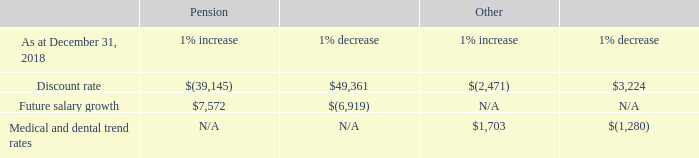30. EMPLOYEE BENEFIT PLANS (cont.)
The above sensitivities are hypothetical and should be used with caution. Changes in amounts based on a one percent variation in assumptions generally cannot be extrapolated because the relationship of the change in assumption to the change in amounts may not be linear. The sensitivities have been calculated independently of changes in other key variables. Changes in one factor may result in changes in another, which could amplify or reduce certain sensitivities.
The Company expects to make contributions of $5.1 million to the defined benefit plans and $0.6 million to the defined contribution plan of Telesat Canada during the next fiscal year.
How much does the company expect to make contributions to to the defined benefit plans and the defined contribution plan respectively during the next fiscal year? $5.1 million, $0.6 million. How much would the pension change if there is a 1% increase and a 1% decrease respectively in the discount rate? $(39,145), $49,361. How much would the pension change if there is a 1% increase and a 1% decrease respectively in the future salary growth? $7,572, $(6,919). What is the value of the expected defined contribution plan as a percentage of the defined benefit plan during the next fiscal year?
Answer scale should be: percent. 0.6/5.1 
Answer: 11.76. What is the difference in pension amount if the future salary growth had a 1% increase and a 1% decrease? 7,572 - (6,919) 
Answer: 14491. What is the difference in pension amount if the discount rate had a 1% increase and a 1% decrease? 49,361 - (39,145) 
Answer: 88506. 